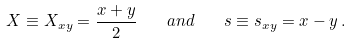Convert formula to latex. <formula><loc_0><loc_0><loc_500><loc_500>X \equiv X _ { x y } = \frac { x + y } { 2 } \quad a n d \quad s \equiv s _ { x y } = x - y \, .</formula> 